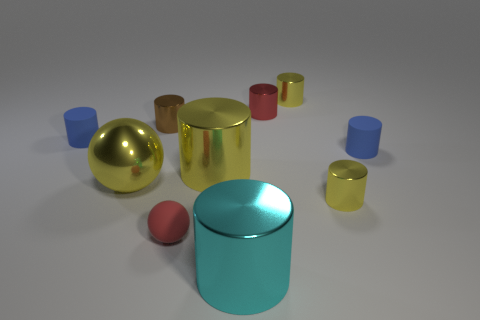How many cylinders are both behind the small brown shiny object and on the right side of the tiny red metal object?
Your response must be concise. 1. What shape is the blue rubber thing on the left side of the big metal sphere?
Offer a terse response. Cylinder. What number of red spheres have the same material as the large cyan object?
Your answer should be compact. 0. Does the big cyan metal object have the same shape as the big yellow shiny thing right of the large yellow sphere?
Keep it short and to the point. Yes. There is a tiny yellow cylinder behind the small matte cylinder to the right of the cyan shiny cylinder; is there a small metal cylinder that is in front of it?
Make the answer very short. Yes. What is the size of the yellow cylinder left of the cyan thing?
Ensure brevity in your answer.  Large. What material is the red cylinder that is the same size as the brown cylinder?
Your answer should be compact. Metal. Do the tiny red metallic thing and the big cyan object have the same shape?
Offer a very short reply. Yes. How many things are either tiny red objects or yellow metallic things that are behind the large metal ball?
Make the answer very short. 4. There is a thing that is the same color as the matte ball; what is it made of?
Your response must be concise. Metal. 